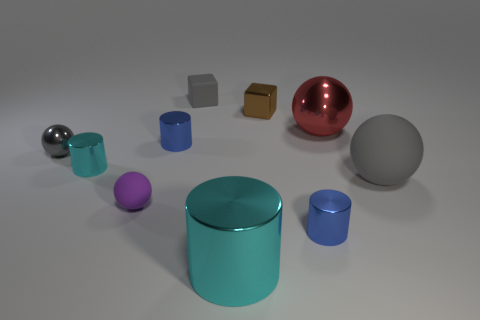Subtract 1 cylinders. How many cylinders are left? 3 Subtract all spheres. How many objects are left? 6 Add 4 brown metallic blocks. How many brown metallic blocks are left? 5 Add 10 big brown matte things. How many big brown matte things exist? 10 Subtract 0 red cylinders. How many objects are left? 10 Subtract all big cyan cylinders. Subtract all large brown rubber cubes. How many objects are left? 9 